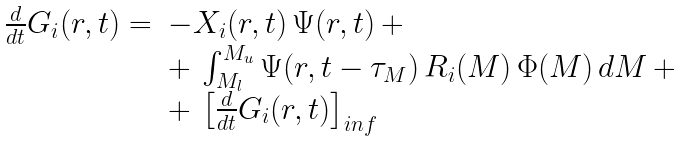<formula> <loc_0><loc_0><loc_500><loc_500>\begin{array} { l l } \frac { d } { d t } G _ { i } ( r , t ) = & - X _ { i } ( r , t ) \, \Psi ( r , t ) \, + \\ & + \, \int _ { M _ { l } } ^ { M _ { u } } \Psi ( r , t - \tau _ { M } ) \, R _ { i } ( M ) \, \Phi ( M ) \, d M \, + \\ & + \, \left [ \frac { d } { d t } G _ { i } ( r , t ) \right ] _ { i n f } \end{array}</formula> 